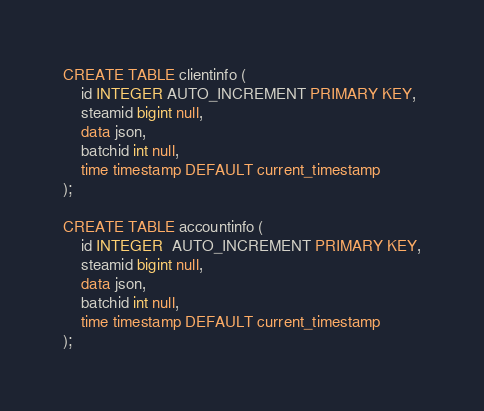<code> <loc_0><loc_0><loc_500><loc_500><_SQL_>CREATE TABLE clientinfo (
	id INTEGER AUTO_INCREMENT PRIMARY KEY,
	steamid bigint null,
	data json,
	batchid int null,
	time timestamp DEFAULT current_timestamp
);

CREATE TABLE accountinfo (
	id INTEGER  AUTO_INCREMENT PRIMARY KEY,
	steamid bigint null,
	data json,
	batchid int null,
	time timestamp DEFAULT current_timestamp
);
</code> 